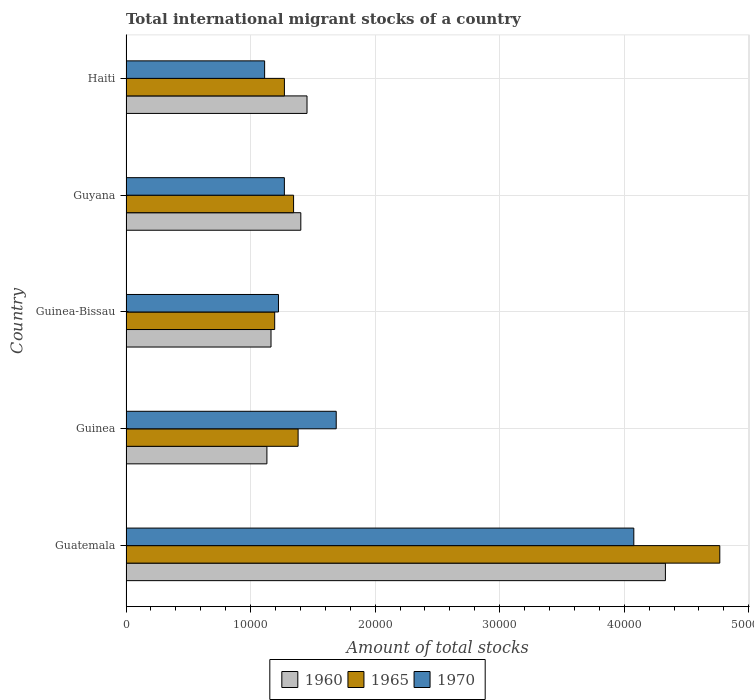Are the number of bars per tick equal to the number of legend labels?
Your answer should be compact. Yes. How many bars are there on the 2nd tick from the top?
Offer a terse response. 3. How many bars are there on the 4th tick from the bottom?
Offer a terse response. 3. What is the label of the 3rd group of bars from the top?
Your answer should be very brief. Guinea-Bissau. In how many cases, is the number of bars for a given country not equal to the number of legend labels?
Provide a short and direct response. 0. What is the amount of total stocks in in 1960 in Guinea-Bissau?
Your answer should be very brief. 1.16e+04. Across all countries, what is the maximum amount of total stocks in in 1960?
Provide a succinct answer. 4.33e+04. Across all countries, what is the minimum amount of total stocks in in 1970?
Your response must be concise. 1.11e+04. In which country was the amount of total stocks in in 1960 maximum?
Your response must be concise. Guatemala. In which country was the amount of total stocks in in 1965 minimum?
Offer a terse response. Guinea-Bissau. What is the total amount of total stocks in in 1965 in the graph?
Give a very brief answer. 9.96e+04. What is the difference between the amount of total stocks in in 1965 in Guatemala and that in Guyana?
Your response must be concise. 3.42e+04. What is the difference between the amount of total stocks in in 1970 in Guatemala and the amount of total stocks in in 1965 in Guinea?
Offer a very short reply. 2.70e+04. What is the average amount of total stocks in in 1970 per country?
Provide a short and direct response. 1.87e+04. What is the difference between the amount of total stocks in in 1960 and amount of total stocks in in 1965 in Guatemala?
Offer a terse response. -4368. In how many countries, is the amount of total stocks in in 1965 greater than 32000 ?
Offer a terse response. 1. What is the ratio of the amount of total stocks in in 1970 in Guatemala to that in Haiti?
Give a very brief answer. 3.66. Is the amount of total stocks in in 1970 in Guinea less than that in Guinea-Bissau?
Your response must be concise. No. What is the difference between the highest and the second highest amount of total stocks in in 1970?
Provide a short and direct response. 2.39e+04. What is the difference between the highest and the lowest amount of total stocks in in 1970?
Keep it short and to the point. 2.96e+04. In how many countries, is the amount of total stocks in in 1970 greater than the average amount of total stocks in in 1970 taken over all countries?
Make the answer very short. 1. What does the 3rd bar from the bottom in Guatemala represents?
Ensure brevity in your answer.  1970. How many bars are there?
Ensure brevity in your answer.  15. Are all the bars in the graph horizontal?
Provide a short and direct response. Yes. How many countries are there in the graph?
Provide a succinct answer. 5. What is the difference between two consecutive major ticks on the X-axis?
Give a very brief answer. 10000. Are the values on the major ticks of X-axis written in scientific E-notation?
Give a very brief answer. No. Does the graph contain any zero values?
Ensure brevity in your answer.  No. Does the graph contain grids?
Offer a very short reply. Yes. Where does the legend appear in the graph?
Give a very brief answer. Bottom center. How are the legend labels stacked?
Provide a short and direct response. Horizontal. What is the title of the graph?
Ensure brevity in your answer.  Total international migrant stocks of a country. What is the label or title of the X-axis?
Offer a very short reply. Amount of total stocks. What is the Amount of total stocks of 1960 in Guatemala?
Provide a succinct answer. 4.33e+04. What is the Amount of total stocks in 1965 in Guatemala?
Provide a succinct answer. 4.77e+04. What is the Amount of total stocks of 1970 in Guatemala?
Make the answer very short. 4.08e+04. What is the Amount of total stocks of 1960 in Guinea?
Give a very brief answer. 1.13e+04. What is the Amount of total stocks of 1965 in Guinea?
Keep it short and to the point. 1.38e+04. What is the Amount of total stocks in 1970 in Guinea?
Keep it short and to the point. 1.69e+04. What is the Amount of total stocks in 1960 in Guinea-Bissau?
Offer a very short reply. 1.16e+04. What is the Amount of total stocks of 1965 in Guinea-Bissau?
Keep it short and to the point. 1.19e+04. What is the Amount of total stocks in 1970 in Guinea-Bissau?
Your answer should be very brief. 1.22e+04. What is the Amount of total stocks in 1960 in Guyana?
Your answer should be very brief. 1.40e+04. What is the Amount of total stocks of 1965 in Guyana?
Provide a succinct answer. 1.35e+04. What is the Amount of total stocks of 1970 in Guyana?
Provide a short and direct response. 1.27e+04. What is the Amount of total stocks in 1960 in Haiti?
Keep it short and to the point. 1.45e+04. What is the Amount of total stocks in 1965 in Haiti?
Keep it short and to the point. 1.27e+04. What is the Amount of total stocks of 1970 in Haiti?
Provide a short and direct response. 1.11e+04. Across all countries, what is the maximum Amount of total stocks of 1960?
Your answer should be very brief. 4.33e+04. Across all countries, what is the maximum Amount of total stocks in 1965?
Ensure brevity in your answer.  4.77e+04. Across all countries, what is the maximum Amount of total stocks of 1970?
Keep it short and to the point. 4.08e+04. Across all countries, what is the minimum Amount of total stocks in 1960?
Your answer should be compact. 1.13e+04. Across all countries, what is the minimum Amount of total stocks in 1965?
Your answer should be compact. 1.19e+04. Across all countries, what is the minimum Amount of total stocks of 1970?
Your answer should be compact. 1.11e+04. What is the total Amount of total stocks of 1960 in the graph?
Your response must be concise. 9.48e+04. What is the total Amount of total stocks in 1965 in the graph?
Your answer should be compact. 9.96e+04. What is the total Amount of total stocks in 1970 in the graph?
Make the answer very short. 9.37e+04. What is the difference between the Amount of total stocks in 1960 in Guatemala and that in Guinea?
Keep it short and to the point. 3.20e+04. What is the difference between the Amount of total stocks of 1965 in Guatemala and that in Guinea?
Your response must be concise. 3.39e+04. What is the difference between the Amount of total stocks of 1970 in Guatemala and that in Guinea?
Your answer should be very brief. 2.39e+04. What is the difference between the Amount of total stocks of 1960 in Guatemala and that in Guinea-Bissau?
Your answer should be compact. 3.17e+04. What is the difference between the Amount of total stocks in 1965 in Guatemala and that in Guinea-Bissau?
Your response must be concise. 3.57e+04. What is the difference between the Amount of total stocks in 1970 in Guatemala and that in Guinea-Bissau?
Your answer should be very brief. 2.85e+04. What is the difference between the Amount of total stocks of 1960 in Guatemala and that in Guyana?
Your response must be concise. 2.93e+04. What is the difference between the Amount of total stocks of 1965 in Guatemala and that in Guyana?
Offer a very short reply. 3.42e+04. What is the difference between the Amount of total stocks of 1970 in Guatemala and that in Guyana?
Ensure brevity in your answer.  2.81e+04. What is the difference between the Amount of total stocks of 1960 in Guatemala and that in Haiti?
Offer a very short reply. 2.88e+04. What is the difference between the Amount of total stocks in 1965 in Guatemala and that in Haiti?
Keep it short and to the point. 3.50e+04. What is the difference between the Amount of total stocks of 1970 in Guatemala and that in Haiti?
Ensure brevity in your answer.  2.96e+04. What is the difference between the Amount of total stocks in 1960 in Guinea and that in Guinea-Bissau?
Your answer should be very brief. -330. What is the difference between the Amount of total stocks of 1965 in Guinea and that in Guinea-Bissau?
Provide a succinct answer. 1880. What is the difference between the Amount of total stocks of 1970 in Guinea and that in Guinea-Bissau?
Offer a very short reply. 4637. What is the difference between the Amount of total stocks in 1960 in Guinea and that in Guyana?
Your response must be concise. -2722. What is the difference between the Amount of total stocks of 1965 in Guinea and that in Guyana?
Provide a succinct answer. 364. What is the difference between the Amount of total stocks of 1970 in Guinea and that in Guyana?
Your answer should be compact. 4163. What is the difference between the Amount of total stocks of 1960 in Guinea and that in Haiti?
Your response must be concise. -3220. What is the difference between the Amount of total stocks of 1965 in Guinea and that in Haiti?
Provide a succinct answer. 1100. What is the difference between the Amount of total stocks in 1970 in Guinea and that in Haiti?
Your response must be concise. 5748. What is the difference between the Amount of total stocks of 1960 in Guinea-Bissau and that in Guyana?
Offer a very short reply. -2392. What is the difference between the Amount of total stocks in 1965 in Guinea-Bissau and that in Guyana?
Your answer should be very brief. -1516. What is the difference between the Amount of total stocks in 1970 in Guinea-Bissau and that in Guyana?
Make the answer very short. -474. What is the difference between the Amount of total stocks in 1960 in Guinea-Bissau and that in Haiti?
Offer a terse response. -2890. What is the difference between the Amount of total stocks in 1965 in Guinea-Bissau and that in Haiti?
Keep it short and to the point. -780. What is the difference between the Amount of total stocks of 1970 in Guinea-Bissau and that in Haiti?
Your answer should be compact. 1111. What is the difference between the Amount of total stocks in 1960 in Guyana and that in Haiti?
Your answer should be very brief. -498. What is the difference between the Amount of total stocks of 1965 in Guyana and that in Haiti?
Keep it short and to the point. 736. What is the difference between the Amount of total stocks of 1970 in Guyana and that in Haiti?
Your answer should be compact. 1585. What is the difference between the Amount of total stocks of 1960 in Guatemala and the Amount of total stocks of 1965 in Guinea?
Give a very brief answer. 2.95e+04. What is the difference between the Amount of total stocks of 1960 in Guatemala and the Amount of total stocks of 1970 in Guinea?
Offer a terse response. 2.64e+04. What is the difference between the Amount of total stocks in 1965 in Guatemala and the Amount of total stocks in 1970 in Guinea?
Give a very brief answer. 3.08e+04. What is the difference between the Amount of total stocks in 1960 in Guatemala and the Amount of total stocks in 1965 in Guinea-Bissau?
Offer a terse response. 3.14e+04. What is the difference between the Amount of total stocks in 1960 in Guatemala and the Amount of total stocks in 1970 in Guinea-Bissau?
Provide a short and direct response. 3.11e+04. What is the difference between the Amount of total stocks of 1965 in Guatemala and the Amount of total stocks of 1970 in Guinea-Bissau?
Offer a terse response. 3.54e+04. What is the difference between the Amount of total stocks of 1960 in Guatemala and the Amount of total stocks of 1965 in Guyana?
Make the answer very short. 2.99e+04. What is the difference between the Amount of total stocks of 1960 in Guatemala and the Amount of total stocks of 1970 in Guyana?
Keep it short and to the point. 3.06e+04. What is the difference between the Amount of total stocks of 1965 in Guatemala and the Amount of total stocks of 1970 in Guyana?
Give a very brief answer. 3.50e+04. What is the difference between the Amount of total stocks in 1960 in Guatemala and the Amount of total stocks in 1965 in Haiti?
Make the answer very short. 3.06e+04. What is the difference between the Amount of total stocks in 1960 in Guatemala and the Amount of total stocks in 1970 in Haiti?
Provide a short and direct response. 3.22e+04. What is the difference between the Amount of total stocks of 1965 in Guatemala and the Amount of total stocks of 1970 in Haiti?
Offer a terse response. 3.65e+04. What is the difference between the Amount of total stocks of 1960 in Guinea and the Amount of total stocks of 1965 in Guinea-Bissau?
Offer a terse response. -625. What is the difference between the Amount of total stocks of 1960 in Guinea and the Amount of total stocks of 1970 in Guinea-Bissau?
Your response must be concise. -928. What is the difference between the Amount of total stocks in 1965 in Guinea and the Amount of total stocks in 1970 in Guinea-Bissau?
Offer a terse response. 1577. What is the difference between the Amount of total stocks of 1960 in Guinea and the Amount of total stocks of 1965 in Guyana?
Give a very brief answer. -2141. What is the difference between the Amount of total stocks in 1960 in Guinea and the Amount of total stocks in 1970 in Guyana?
Provide a succinct answer. -1402. What is the difference between the Amount of total stocks of 1965 in Guinea and the Amount of total stocks of 1970 in Guyana?
Ensure brevity in your answer.  1103. What is the difference between the Amount of total stocks of 1960 in Guinea and the Amount of total stocks of 1965 in Haiti?
Keep it short and to the point. -1405. What is the difference between the Amount of total stocks of 1960 in Guinea and the Amount of total stocks of 1970 in Haiti?
Provide a short and direct response. 183. What is the difference between the Amount of total stocks of 1965 in Guinea and the Amount of total stocks of 1970 in Haiti?
Provide a succinct answer. 2688. What is the difference between the Amount of total stocks of 1960 in Guinea-Bissau and the Amount of total stocks of 1965 in Guyana?
Make the answer very short. -1811. What is the difference between the Amount of total stocks in 1960 in Guinea-Bissau and the Amount of total stocks in 1970 in Guyana?
Offer a very short reply. -1072. What is the difference between the Amount of total stocks in 1965 in Guinea-Bissau and the Amount of total stocks in 1970 in Guyana?
Offer a very short reply. -777. What is the difference between the Amount of total stocks of 1960 in Guinea-Bissau and the Amount of total stocks of 1965 in Haiti?
Provide a succinct answer. -1075. What is the difference between the Amount of total stocks of 1960 in Guinea-Bissau and the Amount of total stocks of 1970 in Haiti?
Make the answer very short. 513. What is the difference between the Amount of total stocks in 1965 in Guinea-Bissau and the Amount of total stocks in 1970 in Haiti?
Your response must be concise. 808. What is the difference between the Amount of total stocks of 1960 in Guyana and the Amount of total stocks of 1965 in Haiti?
Provide a short and direct response. 1317. What is the difference between the Amount of total stocks of 1960 in Guyana and the Amount of total stocks of 1970 in Haiti?
Offer a terse response. 2905. What is the difference between the Amount of total stocks in 1965 in Guyana and the Amount of total stocks in 1970 in Haiti?
Your answer should be very brief. 2324. What is the average Amount of total stocks of 1960 per country?
Provide a succinct answer. 1.90e+04. What is the average Amount of total stocks of 1965 per country?
Make the answer very short. 1.99e+04. What is the average Amount of total stocks in 1970 per country?
Your response must be concise. 1.87e+04. What is the difference between the Amount of total stocks in 1960 and Amount of total stocks in 1965 in Guatemala?
Your response must be concise. -4368. What is the difference between the Amount of total stocks of 1960 and Amount of total stocks of 1970 in Guatemala?
Give a very brief answer. 2537. What is the difference between the Amount of total stocks of 1965 and Amount of total stocks of 1970 in Guatemala?
Your answer should be very brief. 6905. What is the difference between the Amount of total stocks of 1960 and Amount of total stocks of 1965 in Guinea?
Offer a terse response. -2505. What is the difference between the Amount of total stocks in 1960 and Amount of total stocks in 1970 in Guinea?
Offer a terse response. -5565. What is the difference between the Amount of total stocks in 1965 and Amount of total stocks in 1970 in Guinea?
Offer a terse response. -3060. What is the difference between the Amount of total stocks of 1960 and Amount of total stocks of 1965 in Guinea-Bissau?
Your answer should be very brief. -295. What is the difference between the Amount of total stocks in 1960 and Amount of total stocks in 1970 in Guinea-Bissau?
Make the answer very short. -598. What is the difference between the Amount of total stocks in 1965 and Amount of total stocks in 1970 in Guinea-Bissau?
Your answer should be compact. -303. What is the difference between the Amount of total stocks of 1960 and Amount of total stocks of 1965 in Guyana?
Your answer should be very brief. 581. What is the difference between the Amount of total stocks in 1960 and Amount of total stocks in 1970 in Guyana?
Offer a very short reply. 1320. What is the difference between the Amount of total stocks in 1965 and Amount of total stocks in 1970 in Guyana?
Offer a very short reply. 739. What is the difference between the Amount of total stocks of 1960 and Amount of total stocks of 1965 in Haiti?
Provide a short and direct response. 1815. What is the difference between the Amount of total stocks in 1960 and Amount of total stocks in 1970 in Haiti?
Your answer should be compact. 3403. What is the difference between the Amount of total stocks of 1965 and Amount of total stocks of 1970 in Haiti?
Provide a succinct answer. 1588. What is the ratio of the Amount of total stocks in 1960 in Guatemala to that in Guinea?
Make the answer very short. 3.83. What is the ratio of the Amount of total stocks of 1965 in Guatemala to that in Guinea?
Make the answer very short. 3.45. What is the ratio of the Amount of total stocks in 1970 in Guatemala to that in Guinea?
Ensure brevity in your answer.  2.42. What is the ratio of the Amount of total stocks in 1960 in Guatemala to that in Guinea-Bissau?
Your answer should be compact. 3.72. What is the ratio of the Amount of total stocks in 1965 in Guatemala to that in Guinea-Bissau?
Provide a succinct answer. 3.99. What is the ratio of the Amount of total stocks of 1970 in Guatemala to that in Guinea-Bissau?
Provide a succinct answer. 3.33. What is the ratio of the Amount of total stocks of 1960 in Guatemala to that in Guyana?
Your answer should be very brief. 3.09. What is the ratio of the Amount of total stocks of 1965 in Guatemala to that in Guyana?
Ensure brevity in your answer.  3.54. What is the ratio of the Amount of total stocks of 1970 in Guatemala to that in Guyana?
Offer a terse response. 3.21. What is the ratio of the Amount of total stocks of 1960 in Guatemala to that in Haiti?
Offer a very short reply. 2.98. What is the ratio of the Amount of total stocks in 1965 in Guatemala to that in Haiti?
Offer a terse response. 3.75. What is the ratio of the Amount of total stocks in 1970 in Guatemala to that in Haiti?
Provide a succinct answer. 3.66. What is the ratio of the Amount of total stocks in 1960 in Guinea to that in Guinea-Bissau?
Provide a short and direct response. 0.97. What is the ratio of the Amount of total stocks in 1965 in Guinea to that in Guinea-Bissau?
Ensure brevity in your answer.  1.16. What is the ratio of the Amount of total stocks in 1970 in Guinea to that in Guinea-Bissau?
Your response must be concise. 1.38. What is the ratio of the Amount of total stocks in 1960 in Guinea to that in Guyana?
Your response must be concise. 0.81. What is the ratio of the Amount of total stocks in 1965 in Guinea to that in Guyana?
Make the answer very short. 1.03. What is the ratio of the Amount of total stocks of 1970 in Guinea to that in Guyana?
Offer a terse response. 1.33. What is the ratio of the Amount of total stocks in 1960 in Guinea to that in Haiti?
Offer a terse response. 0.78. What is the ratio of the Amount of total stocks in 1965 in Guinea to that in Haiti?
Your answer should be very brief. 1.09. What is the ratio of the Amount of total stocks in 1970 in Guinea to that in Haiti?
Provide a succinct answer. 1.52. What is the ratio of the Amount of total stocks in 1960 in Guinea-Bissau to that in Guyana?
Offer a very short reply. 0.83. What is the ratio of the Amount of total stocks in 1965 in Guinea-Bissau to that in Guyana?
Provide a short and direct response. 0.89. What is the ratio of the Amount of total stocks in 1970 in Guinea-Bissau to that in Guyana?
Provide a succinct answer. 0.96. What is the ratio of the Amount of total stocks in 1960 in Guinea-Bissau to that in Haiti?
Give a very brief answer. 0.8. What is the ratio of the Amount of total stocks of 1965 in Guinea-Bissau to that in Haiti?
Your response must be concise. 0.94. What is the ratio of the Amount of total stocks in 1970 in Guinea-Bissau to that in Haiti?
Provide a succinct answer. 1.1. What is the ratio of the Amount of total stocks of 1960 in Guyana to that in Haiti?
Keep it short and to the point. 0.97. What is the ratio of the Amount of total stocks of 1965 in Guyana to that in Haiti?
Make the answer very short. 1.06. What is the ratio of the Amount of total stocks of 1970 in Guyana to that in Haiti?
Provide a succinct answer. 1.14. What is the difference between the highest and the second highest Amount of total stocks of 1960?
Give a very brief answer. 2.88e+04. What is the difference between the highest and the second highest Amount of total stocks of 1965?
Ensure brevity in your answer.  3.39e+04. What is the difference between the highest and the second highest Amount of total stocks in 1970?
Ensure brevity in your answer.  2.39e+04. What is the difference between the highest and the lowest Amount of total stocks of 1960?
Give a very brief answer. 3.20e+04. What is the difference between the highest and the lowest Amount of total stocks in 1965?
Your answer should be very brief. 3.57e+04. What is the difference between the highest and the lowest Amount of total stocks in 1970?
Offer a terse response. 2.96e+04. 